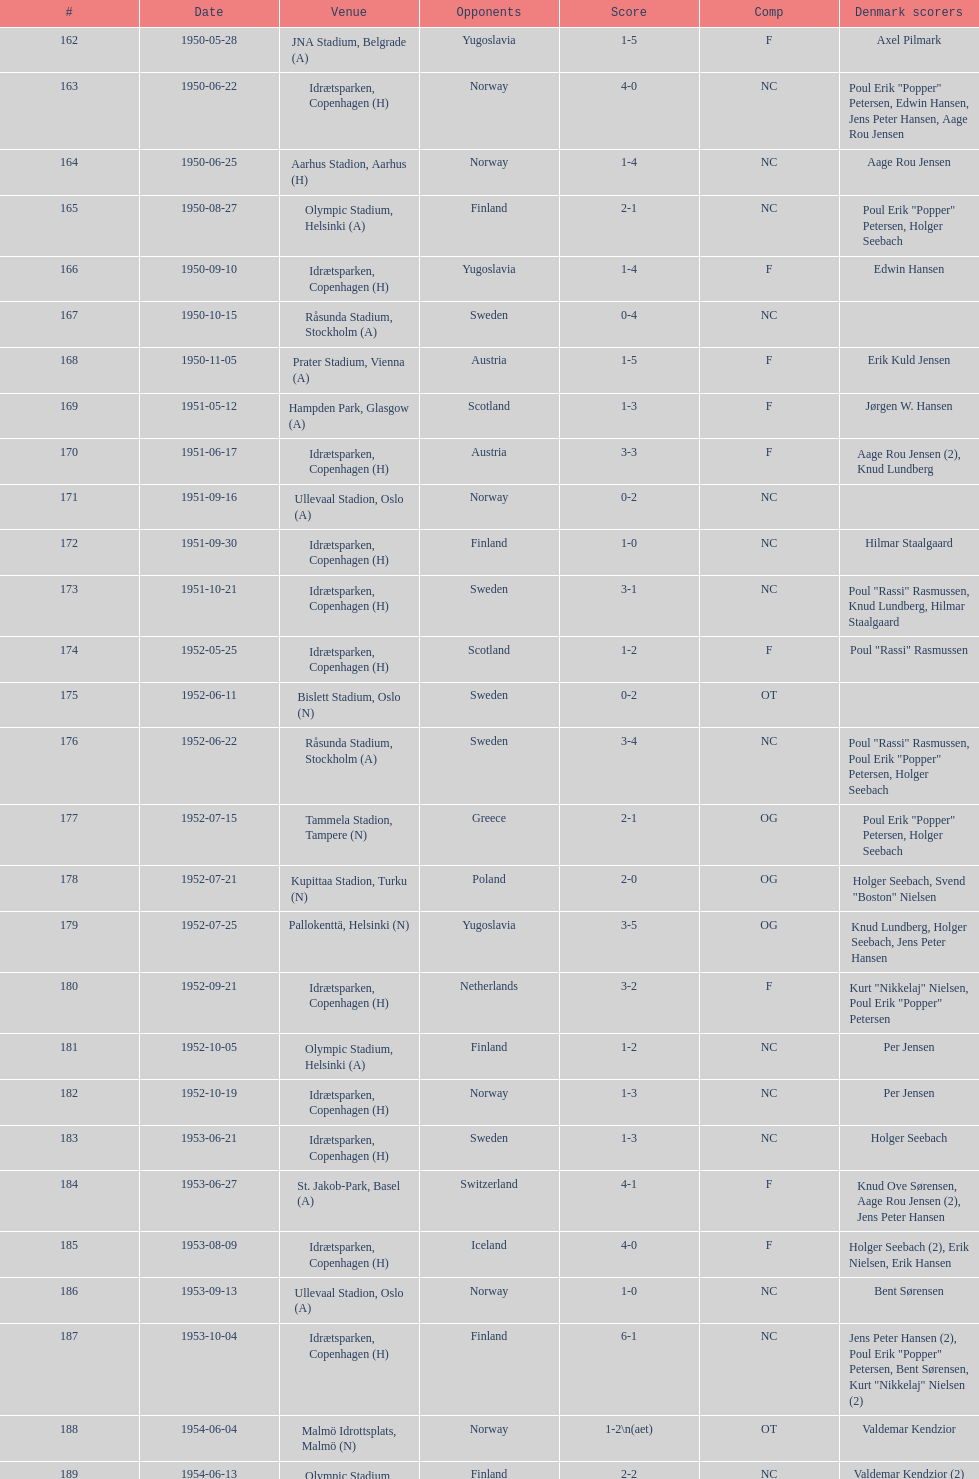Is denmark superior when competing against sweden or england? Sweden. Write the full table. {'header': ['#', 'Date', 'Venue', 'Opponents', 'Score', 'Comp', 'Denmark scorers'], 'rows': [['162', '1950-05-28', 'JNA Stadium, Belgrade (A)', 'Yugoslavia', '1-5', 'F', 'Axel Pilmark'], ['163', '1950-06-22', 'Idrætsparken, Copenhagen (H)', 'Norway', '4-0', 'NC', 'Poul Erik "Popper" Petersen, Edwin Hansen, Jens Peter Hansen, Aage Rou Jensen'], ['164', '1950-06-25', 'Aarhus Stadion, Aarhus (H)', 'Norway', '1-4', 'NC', 'Aage Rou Jensen'], ['165', '1950-08-27', 'Olympic Stadium, Helsinki (A)', 'Finland', '2-1', 'NC', 'Poul Erik "Popper" Petersen, Holger Seebach'], ['166', '1950-09-10', 'Idrætsparken, Copenhagen (H)', 'Yugoslavia', '1-4', 'F', 'Edwin Hansen'], ['167', '1950-10-15', 'Råsunda Stadium, Stockholm (A)', 'Sweden', '0-4', 'NC', ''], ['168', '1950-11-05', 'Prater Stadium, Vienna (A)', 'Austria', '1-5', 'F', 'Erik Kuld Jensen'], ['169', '1951-05-12', 'Hampden Park, Glasgow (A)', 'Scotland', '1-3', 'F', 'Jørgen W. Hansen'], ['170', '1951-06-17', 'Idrætsparken, Copenhagen (H)', 'Austria', '3-3', 'F', 'Aage Rou Jensen (2), Knud Lundberg'], ['171', '1951-09-16', 'Ullevaal Stadion, Oslo (A)', 'Norway', '0-2', 'NC', ''], ['172', '1951-09-30', 'Idrætsparken, Copenhagen (H)', 'Finland', '1-0', 'NC', 'Hilmar Staalgaard'], ['173', '1951-10-21', 'Idrætsparken, Copenhagen (H)', 'Sweden', '3-1', 'NC', 'Poul "Rassi" Rasmussen, Knud Lundberg, Hilmar Staalgaard'], ['174', '1952-05-25', 'Idrætsparken, Copenhagen (H)', 'Scotland', '1-2', 'F', 'Poul "Rassi" Rasmussen'], ['175', '1952-06-11', 'Bislett Stadium, Oslo (N)', 'Sweden', '0-2', 'OT', ''], ['176', '1952-06-22', 'Råsunda Stadium, Stockholm (A)', 'Sweden', '3-4', 'NC', 'Poul "Rassi" Rasmussen, Poul Erik "Popper" Petersen, Holger Seebach'], ['177', '1952-07-15', 'Tammela Stadion, Tampere (N)', 'Greece', '2-1', 'OG', 'Poul Erik "Popper" Petersen, Holger Seebach'], ['178', '1952-07-21', 'Kupittaa Stadion, Turku (N)', 'Poland', '2-0', 'OG', 'Holger Seebach, Svend "Boston" Nielsen'], ['179', '1952-07-25', 'Pallokenttä, Helsinki (N)', 'Yugoslavia', '3-5', 'OG', 'Knud Lundberg, Holger Seebach, Jens Peter Hansen'], ['180', '1952-09-21', 'Idrætsparken, Copenhagen (H)', 'Netherlands', '3-2', 'F', 'Kurt "Nikkelaj" Nielsen, Poul Erik "Popper" Petersen'], ['181', '1952-10-05', 'Olympic Stadium, Helsinki (A)', 'Finland', '1-2', 'NC', 'Per Jensen'], ['182', '1952-10-19', 'Idrætsparken, Copenhagen (H)', 'Norway', '1-3', 'NC', 'Per Jensen'], ['183', '1953-06-21', 'Idrætsparken, Copenhagen (H)', 'Sweden', '1-3', 'NC', 'Holger Seebach'], ['184', '1953-06-27', 'St. Jakob-Park, Basel (A)', 'Switzerland', '4-1', 'F', 'Knud Ove Sørensen, Aage Rou Jensen (2), Jens Peter Hansen'], ['185', '1953-08-09', 'Idrætsparken, Copenhagen (H)', 'Iceland', '4-0', 'F', 'Holger Seebach (2), Erik Nielsen, Erik Hansen'], ['186', '1953-09-13', 'Ullevaal Stadion, Oslo (A)', 'Norway', '1-0', 'NC', 'Bent Sørensen'], ['187', '1953-10-04', 'Idrætsparken, Copenhagen (H)', 'Finland', '6-1', 'NC', 'Jens Peter Hansen (2), Poul Erik "Popper" Petersen, Bent Sørensen, Kurt "Nikkelaj" Nielsen (2)'], ['188', '1954-06-04', 'Malmö Idrottsplats, Malmö (N)', 'Norway', '1-2\\n(aet)', 'OT', 'Valdemar Kendzior'], ['189', '1954-06-13', 'Olympic Stadium, Helsinki (A)', 'Finland', '2-2', 'NC', 'Valdemar Kendzior (2)'], ['190', '1954-09-19', 'Idrætsparken, Copenhagen (H)', 'Switzerland', '1-1', 'F', 'Jørgen Olesen'], ['191', '1954-10-10', 'Råsunda Stadium, Stockholm (A)', 'Sweden', '2-5', 'NC', 'Jens Peter Hansen, Bent Sørensen'], ['192', '1954-10-31', 'Idrætsparken, Copenhagen (H)', 'Norway', '0-1', 'NC', ''], ['193', '1955-03-13', 'Olympic Stadium, Amsterdam (A)', 'Netherlands', '1-1', 'F', 'Vagn Birkeland'], ['194', '1955-05-15', 'Idrætsparken, Copenhagen (H)', 'Hungary', '0-6', 'F', ''], ['195', '1955-06-19', 'Idrætsparken, Copenhagen (H)', 'Finland', '2-1', 'NC', 'Jens Peter Hansen (2)'], ['196', '1955-06-03', 'Melavollur, Reykjavík (A)', 'Iceland', '4-0', 'F', 'Aage Rou Jensen, Jens Peter Hansen, Poul Pedersen (2)'], ['197', '1955-09-11', 'Ullevaal Stadion, Oslo (A)', 'Norway', '1-1', 'NC', 'Jørgen Jacobsen'], ['198', '1955-10-02', 'Idrætsparken, Copenhagen (H)', 'England', '1-5', 'NC', 'Knud Lundberg'], ['199', '1955-10-16', 'Idrætsparken, Copenhagen (H)', 'Sweden', '3-3', 'NC', 'Ove Andersen (2), Knud Lundberg'], ['200', '1956-05-23', 'Dynamo Stadium, Moscow (A)', 'USSR', '1-5', 'F', 'Knud Lundberg'], ['201', '1956-06-24', 'Idrætsparken, Copenhagen (H)', 'Norway', '2-3', 'NC', 'Knud Lundberg, Poul Pedersen'], ['202', '1956-07-01', 'Idrætsparken, Copenhagen (H)', 'USSR', '2-5', 'F', 'Ove Andersen, Aage Rou Jensen'], ['203', '1956-09-16', 'Olympic Stadium, Helsinki (A)', 'Finland', '4-0', 'NC', 'Poul Pedersen, Jørgen Hansen, Ove Andersen (2)'], ['204', '1956-10-03', 'Dalymount Park, Dublin (A)', 'Republic of Ireland', '1-2', 'WCQ', 'Aage Rou Jensen'], ['205', '1956-10-21', 'Råsunda Stadium, Stockholm (A)', 'Sweden', '1-1', 'NC', 'Jens Peter Hansen'], ['206', '1956-11-04', 'Idrætsparken, Copenhagen (H)', 'Netherlands', '2-2', 'F', 'Jørgen Olesen, Knud Lundberg'], ['207', '1956-12-05', 'Molineux, Wolverhampton (A)', 'England', '2-5', 'WCQ', 'Ove Bech Nielsen (2)'], ['208', '1957-05-15', 'Idrætsparken, Copenhagen (H)', 'England', '1-4', 'WCQ', 'John Jensen'], ['209', '1957-05-26', 'Idrætsparken, Copenhagen (H)', 'Bulgaria', '1-1', 'F', 'Aage Rou Jensen'], ['210', '1957-06-18', 'Olympic Stadium, Helsinki (A)', 'Finland', '0-2', 'OT', ''], ['211', '1957-06-19', 'Tammela Stadion, Tampere (N)', 'Norway', '2-0', 'OT', 'Egon Jensen, Jørgen Hansen'], ['212', '1957-06-30', 'Idrætsparken, Copenhagen (H)', 'Sweden', '1-2', 'NC', 'Jens Peter Hansen'], ['213', '1957-07-10', 'Laugardalsvöllur, Reykjavík (A)', 'Iceland', '6-2', 'OT', 'Egon Jensen (3), Poul Pedersen, Jens Peter Hansen (2)'], ['214', '1957-09-22', 'Ullevaal Stadion, Oslo (A)', 'Norway', '2-2', 'NC', 'Poul Pedersen, Peder Kjær'], ['215', '1957-10-02', 'Idrætsparken, Copenhagen (H)', 'Republic of Ireland', '0-2', 'WCQ', ''], ['216', '1957-10-13', 'Idrætsparken, Copenhagen (H)', 'Finland', '3-0', 'NC', 'Finn Alfred Hansen, Ove Bech Nielsen, Mogens Machon'], ['217', '1958-05-15', 'Aarhus Stadion, Aarhus (H)', 'Curaçao', '3-2', 'F', 'Poul Pedersen, Henning Enoksen (2)'], ['218', '1958-05-25', 'Idrætsparken, Copenhagen (H)', 'Poland', '3-2', 'F', 'Jørn Sørensen, Poul Pedersen (2)'], ['219', '1958-06-29', 'Idrætsparken, Copenhagen (H)', 'Norway', '1-2', 'NC', 'Poul Pedersen'], ['220', '1958-09-14', 'Olympic Stadium, Helsinki (A)', 'Finland', '4-1', 'NC', 'Poul Pedersen, Mogens Machon, John Danielsen (2)'], ['221', '1958-09-24', 'Idrætsparken, Copenhagen (H)', 'West Germany', '1-1', 'F', 'Henning Enoksen'], ['222', '1958-10-15', 'Idrætsparken, Copenhagen (H)', 'Netherlands', '1-5', 'F', 'Henning Enoksen'], ['223', '1958-10-26', 'Råsunda Stadium, Stockholm (A)', 'Sweden', '4-4', 'NC', 'Ole Madsen (2), Henning Enoksen, Jørn Sørensen'], ['224', '1959-06-21', 'Idrætsparken, Copenhagen (H)', 'Sweden', '0-6', 'NC', ''], ['225', '1959-06-26', 'Laugardalsvöllur, Reykjavík (A)', 'Iceland', '4-2', 'OGQ', 'Jens Peter Hansen (2), Ole Madsen (2)'], ['226', '1959-07-02', 'Idrætsparken, Copenhagen (H)', 'Norway', '2-1', 'OGQ', 'Henning Enoksen, Ole Madsen'], ['227', '1959-08-18', 'Idrætsparken, Copenhagen (H)', 'Iceland', '1-1', 'OGQ', 'Henning Enoksen'], ['228', '1959-09-13', 'Ullevaal Stadion, Oslo (A)', 'Norway', '4-2', 'OGQ\\nNC', 'Harald Nielsen, Henning Enoksen (2), Poul Pedersen'], ['229', '1959-09-23', 'Idrætsparken, Copenhagen (H)', 'Czechoslovakia', '2-2', 'ENQ', 'Poul Pedersen, Bent Hansen'], ['230', '1959-10-04', 'Idrætsparken, Copenhagen (H)', 'Finland', '4-0', 'NC', 'Harald Nielsen (3), John Kramer'], ['231', '1959-10-18', 'Stadion Za Lužánkami, Brno (A)', 'Czechoslovakia', '1-5', 'ENQ', 'John Kramer'], ['232', '1959-12-02', 'Olympic Stadium, Athens (A)', 'Greece', '3-1', 'F', 'Henning Enoksen (2), Poul Pedersen'], ['233', '1959-12-06', 'Vasil Levski National Stadium, Sofia (A)', 'Bulgaria', '1-2', 'F', 'Henning Enoksen']]} 